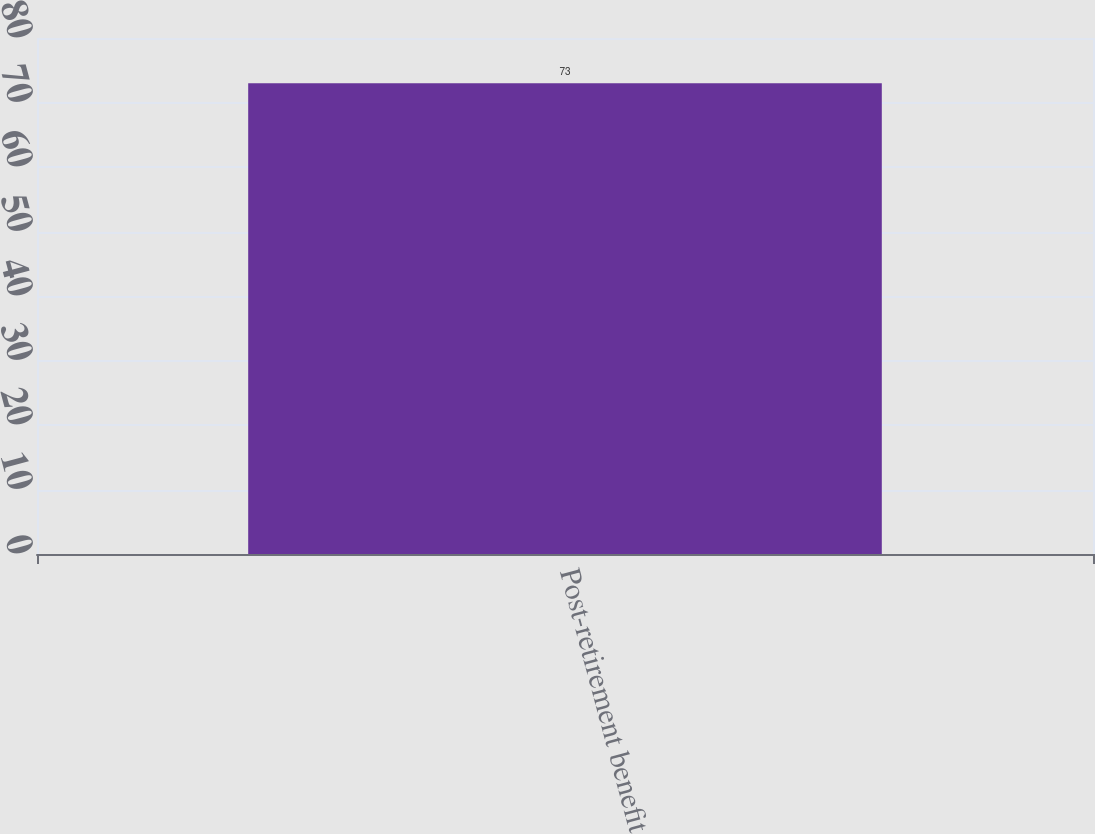<chart> <loc_0><loc_0><loc_500><loc_500><bar_chart><fcel>Post-retirement benefit<nl><fcel>73<nl></chart> 